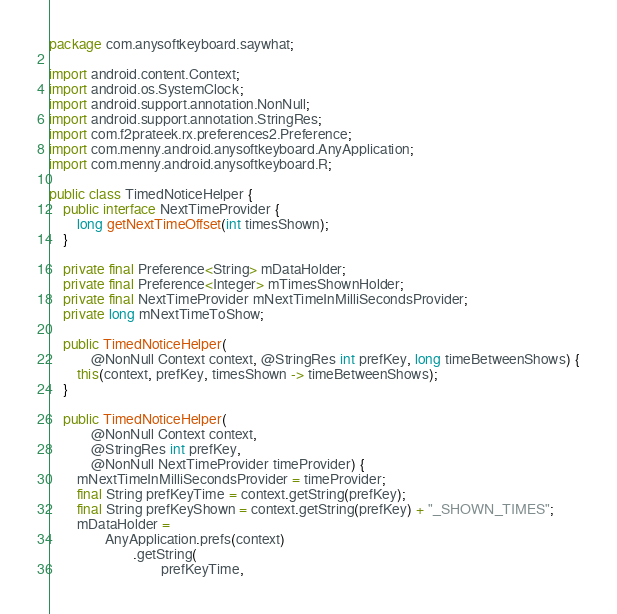<code> <loc_0><loc_0><loc_500><loc_500><_Java_>package com.anysoftkeyboard.saywhat;

import android.content.Context;
import android.os.SystemClock;
import android.support.annotation.NonNull;
import android.support.annotation.StringRes;
import com.f2prateek.rx.preferences2.Preference;
import com.menny.android.anysoftkeyboard.AnyApplication;
import com.menny.android.anysoftkeyboard.R;

public class TimedNoticeHelper {
    public interface NextTimeProvider {
        long getNextTimeOffset(int timesShown);
    }

    private final Preference<String> mDataHolder;
    private final Preference<Integer> mTimesShownHolder;
    private final NextTimeProvider mNextTimeInMilliSecondsProvider;
    private long mNextTimeToShow;

    public TimedNoticeHelper(
            @NonNull Context context, @StringRes int prefKey, long timeBetweenShows) {
        this(context, prefKey, timesShown -> timeBetweenShows);
    }

    public TimedNoticeHelper(
            @NonNull Context context,
            @StringRes int prefKey,
            @NonNull NextTimeProvider timeProvider) {
        mNextTimeInMilliSecondsProvider = timeProvider;
        final String prefKeyTime = context.getString(prefKey);
        final String prefKeyShown = context.getString(prefKey) + "_SHOWN_TIMES";
        mDataHolder =
                AnyApplication.prefs(context)
                        .getString(
                                prefKeyTime,</code> 